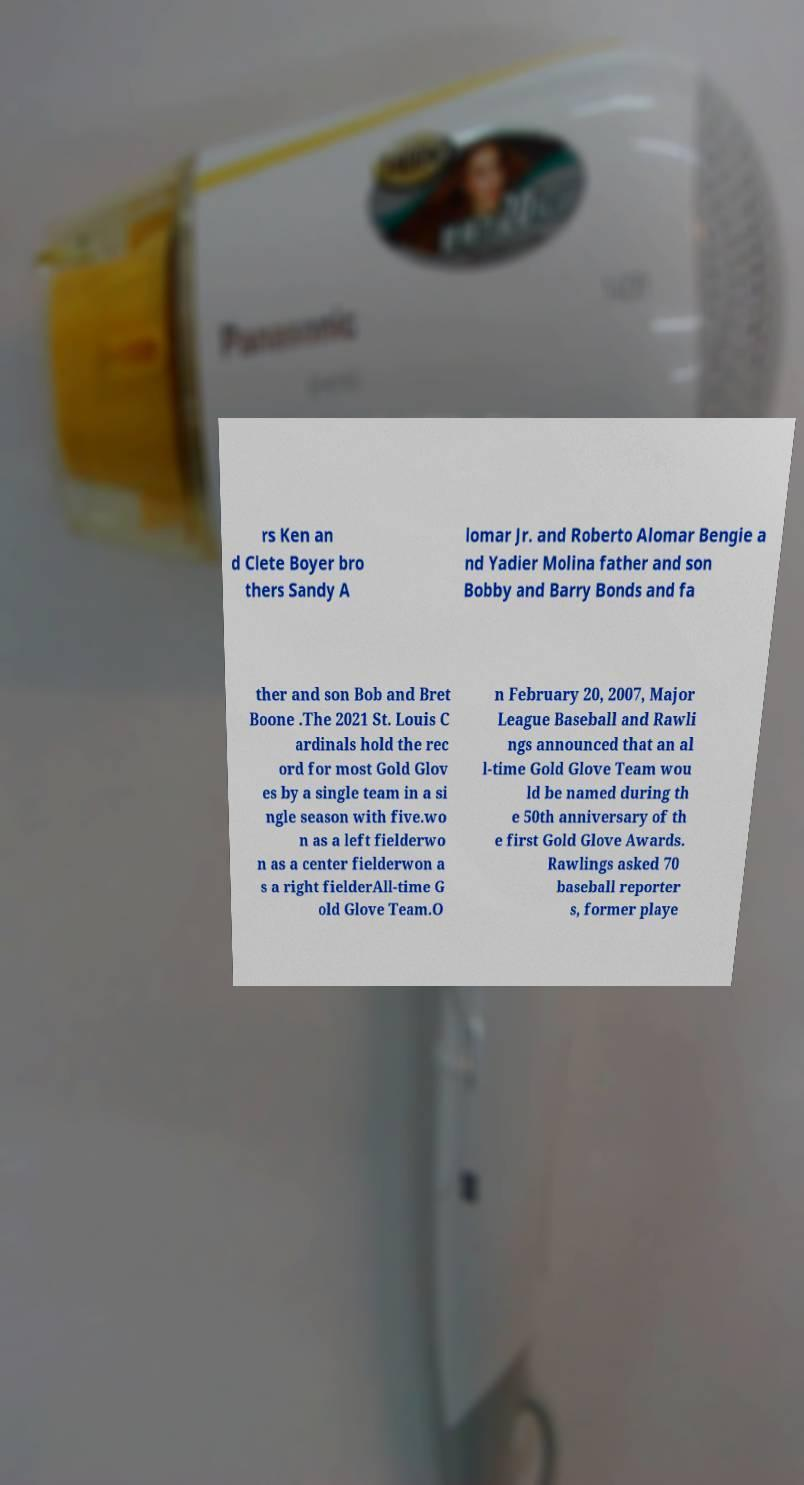I need the written content from this picture converted into text. Can you do that? rs Ken an d Clete Boyer bro thers Sandy A lomar Jr. and Roberto Alomar Bengie a nd Yadier Molina father and son Bobby and Barry Bonds and fa ther and son Bob and Bret Boone .The 2021 St. Louis C ardinals hold the rec ord for most Gold Glov es by a single team in a si ngle season with five.wo n as a left fielderwo n as a center fielderwon a s a right fielderAll-time G old Glove Team.O n February 20, 2007, Major League Baseball and Rawli ngs announced that an al l-time Gold Glove Team wou ld be named during th e 50th anniversary of th e first Gold Glove Awards. Rawlings asked 70 baseball reporter s, former playe 